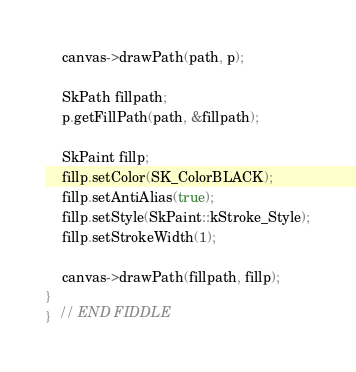Convert code to text. <code><loc_0><loc_0><loc_500><loc_500><_C++_>
    canvas->drawPath(path, p);

    SkPath fillpath;
    p.getFillPath(path, &fillpath);

    SkPaint fillp;
    fillp.setColor(SK_ColorBLACK);
    fillp.setAntiAlias(true);
    fillp.setStyle(SkPaint::kStroke_Style);
    fillp.setStrokeWidth(1);

    canvas->drawPath(fillpath, fillp);
}
}  // END FIDDLE
</code> 